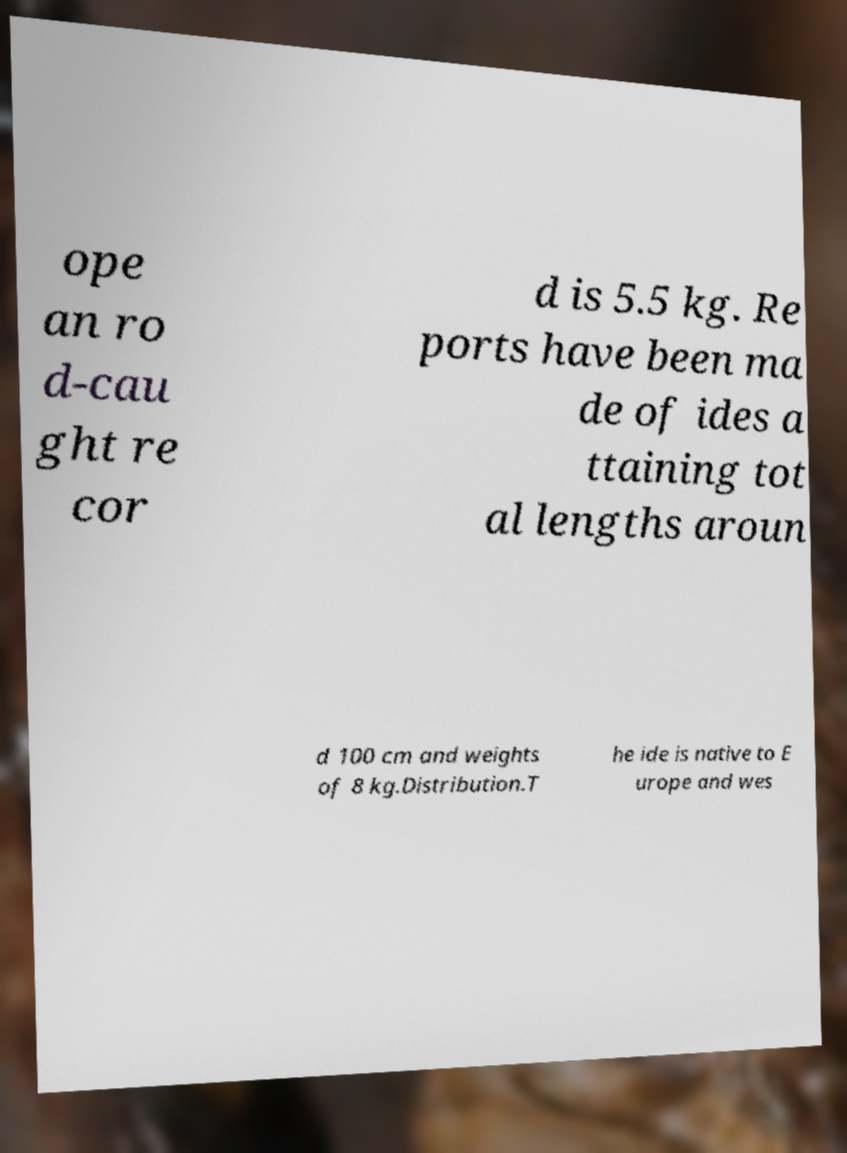Please identify and transcribe the text found in this image. ope an ro d-cau ght re cor d is 5.5 kg. Re ports have been ma de of ides a ttaining tot al lengths aroun d 100 cm and weights of 8 kg.Distribution.T he ide is native to E urope and wes 